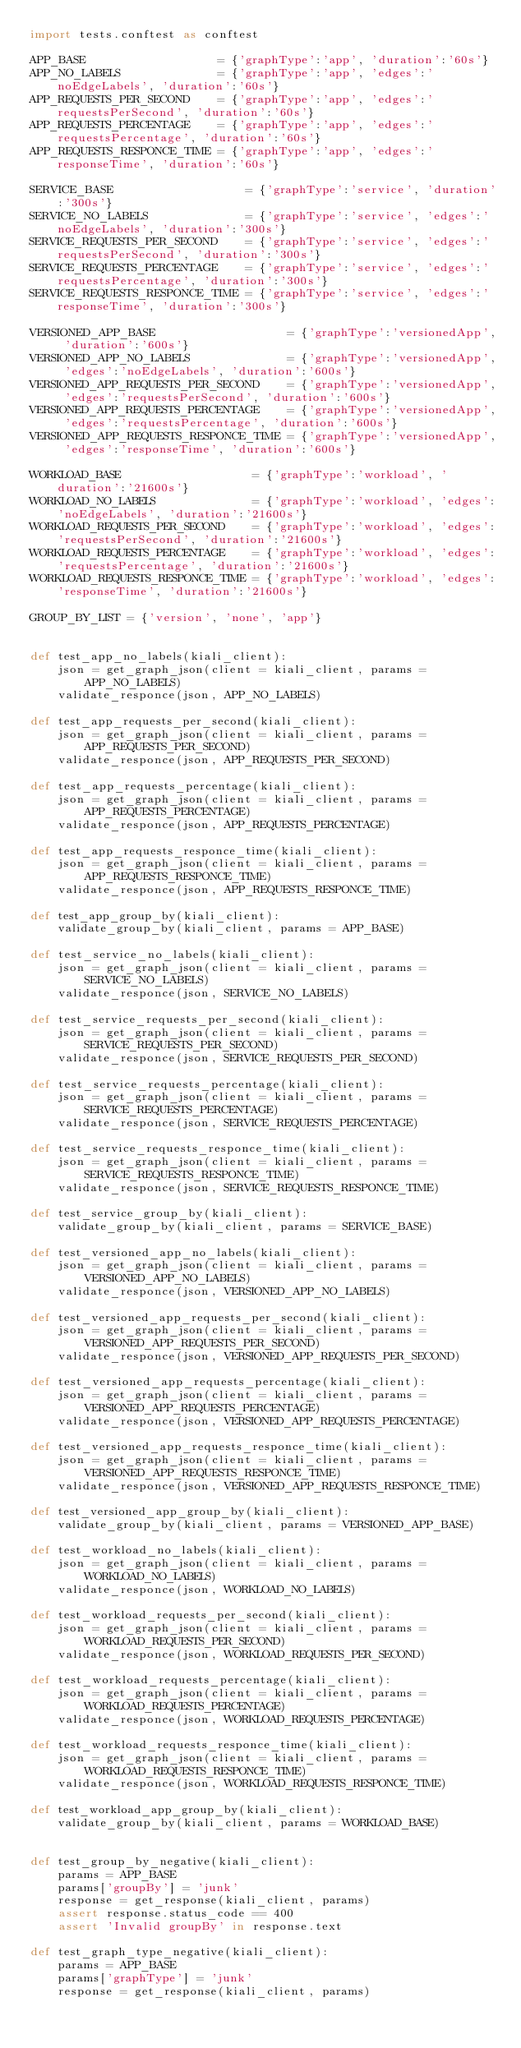Convert code to text. <code><loc_0><loc_0><loc_500><loc_500><_Python_>import tests.conftest as conftest

APP_BASE                   = {'graphType':'app', 'duration':'60s'}
APP_NO_LABELS              = {'graphType':'app', 'edges':'noEdgeLabels', 'duration':'60s'}
APP_REQUESTS_PER_SECOND    = {'graphType':'app', 'edges':'requestsPerSecond', 'duration':'60s'}
APP_REQUESTS_PERCENTAGE    = {'graphType':'app', 'edges':'requestsPercentage', 'duration':'60s'}
APP_REQUESTS_RESPONCE_TIME = {'graphType':'app', 'edges':'responseTime', 'duration':'60s'}

SERVICE_BASE                   = {'graphType':'service', 'duration':'300s'}
SERVICE_NO_LABELS              = {'graphType':'service', 'edges':'noEdgeLabels', 'duration':'300s'}
SERVICE_REQUESTS_PER_SECOND    = {'graphType':'service', 'edges':'requestsPerSecond', 'duration':'300s'}
SERVICE_REQUESTS_PERCENTAGE    = {'graphType':'service', 'edges':'requestsPercentage', 'duration':'300s'}
SERVICE_REQUESTS_RESPONCE_TIME = {'graphType':'service', 'edges':'responseTime', 'duration':'300s'}

VERSIONED_APP_BASE                   = {'graphType':'versionedApp', 'duration':'600s'}
VERSIONED_APP_NO_LABELS              = {'graphType':'versionedApp', 'edges':'noEdgeLabels', 'duration':'600s'}
VERSIONED_APP_REQUESTS_PER_SECOND    = {'graphType':'versionedApp', 'edges':'requestsPerSecond', 'duration':'600s'}
VERSIONED_APP_REQUESTS_PERCENTAGE    = {'graphType':'versionedApp', 'edges':'requestsPercentage', 'duration':'600s'}
VERSIONED_APP_REQUESTS_RESPONCE_TIME = {'graphType':'versionedApp', 'edges':'responseTime', 'duration':'600s'}

WORKLOAD_BASE                   = {'graphType':'workload', 'duration':'21600s'}
WORKLOAD_NO_LABELS              = {'graphType':'workload', 'edges':'noEdgeLabels', 'duration':'21600s'}
WORKLOAD_REQUESTS_PER_SECOND    = {'graphType':'workload', 'edges':'requestsPerSecond', 'duration':'21600s'}
WORKLOAD_REQUESTS_PERCENTAGE    = {'graphType':'workload', 'edges':'requestsPercentage', 'duration':'21600s'}
WORKLOAD_REQUESTS_RESPONCE_TIME = {'graphType':'workload', 'edges':'responseTime', 'duration':'21600s'}

GROUP_BY_LIST = {'version', 'none', 'app'}


def test_app_no_labels(kiali_client):
    json = get_graph_json(client = kiali_client, params = APP_NO_LABELS)
    validate_responce(json, APP_NO_LABELS)

def test_app_requests_per_second(kiali_client):
    json = get_graph_json(client = kiali_client, params = APP_REQUESTS_PER_SECOND)
    validate_responce(json, APP_REQUESTS_PER_SECOND)

def test_app_requests_percentage(kiali_client):
    json = get_graph_json(client = kiali_client, params = APP_REQUESTS_PERCENTAGE)
    validate_responce(json, APP_REQUESTS_PERCENTAGE)

def test_app_requests_responce_time(kiali_client):
    json = get_graph_json(client = kiali_client, params = APP_REQUESTS_RESPONCE_TIME)
    validate_responce(json, APP_REQUESTS_RESPONCE_TIME)

def test_app_group_by(kiali_client):
    validate_group_by(kiali_client, params = APP_BASE)

def test_service_no_labels(kiali_client):
    json = get_graph_json(client = kiali_client, params = SERVICE_NO_LABELS)
    validate_responce(json, SERVICE_NO_LABELS)

def test_service_requests_per_second(kiali_client):
    json = get_graph_json(client = kiali_client, params = SERVICE_REQUESTS_PER_SECOND)
    validate_responce(json, SERVICE_REQUESTS_PER_SECOND)

def test_service_requests_percentage(kiali_client):
    json = get_graph_json(client = kiali_client, params = SERVICE_REQUESTS_PERCENTAGE)
    validate_responce(json, SERVICE_REQUESTS_PERCENTAGE)

def test_service_requests_responce_time(kiali_client):
    json = get_graph_json(client = kiali_client, params = SERVICE_REQUESTS_RESPONCE_TIME)
    validate_responce(json, SERVICE_REQUESTS_RESPONCE_TIME)

def test_service_group_by(kiali_client):
    validate_group_by(kiali_client, params = SERVICE_BASE)

def test_versioned_app_no_labels(kiali_client):
    json = get_graph_json(client = kiali_client, params = VERSIONED_APP_NO_LABELS)
    validate_responce(json, VERSIONED_APP_NO_LABELS)

def test_versioned_app_requests_per_second(kiali_client):
    json = get_graph_json(client = kiali_client, params = VERSIONED_APP_REQUESTS_PER_SECOND)
    validate_responce(json, VERSIONED_APP_REQUESTS_PER_SECOND)

def test_versioned_app_requests_percentage(kiali_client):
    json = get_graph_json(client = kiali_client, params = VERSIONED_APP_REQUESTS_PERCENTAGE)
    validate_responce(json, VERSIONED_APP_REQUESTS_PERCENTAGE)

def test_versioned_app_requests_responce_time(kiali_client):
    json = get_graph_json(client = kiali_client, params = VERSIONED_APP_REQUESTS_RESPONCE_TIME)
    validate_responce(json, VERSIONED_APP_REQUESTS_RESPONCE_TIME)

def test_versioned_app_group_by(kiali_client):
    validate_group_by(kiali_client, params = VERSIONED_APP_BASE)

def test_workload_no_labels(kiali_client):
    json = get_graph_json(client = kiali_client, params = WORKLOAD_NO_LABELS)
    validate_responce(json, WORKLOAD_NO_LABELS)

def test_workload_requests_per_second(kiali_client):
    json = get_graph_json(client = kiali_client, params = WORKLOAD_REQUESTS_PER_SECOND)
    validate_responce(json, WORKLOAD_REQUESTS_PER_SECOND)

def test_workload_requests_percentage(kiali_client):
    json = get_graph_json(client = kiali_client, params = WORKLOAD_REQUESTS_PERCENTAGE)
    validate_responce(json, WORKLOAD_REQUESTS_PERCENTAGE)

def test_workload_requests_responce_time(kiali_client):
    json = get_graph_json(client = kiali_client, params = WORKLOAD_REQUESTS_RESPONCE_TIME)
    validate_responce(json, WORKLOAD_REQUESTS_RESPONCE_TIME)

def test_workload_app_group_by(kiali_client):
    validate_group_by(kiali_client, params = WORKLOAD_BASE)


def test_group_by_negative(kiali_client):
    params = APP_BASE
    params['groupBy'] = 'junk'
    response = get_response(kiali_client, params)
    assert response.status_code == 400
    assert 'Invalid groupBy' in response.text

def test_graph_type_negative(kiali_client):
    params = APP_BASE
    params['graphType'] = 'junk'
    response = get_response(kiali_client, params)</code> 